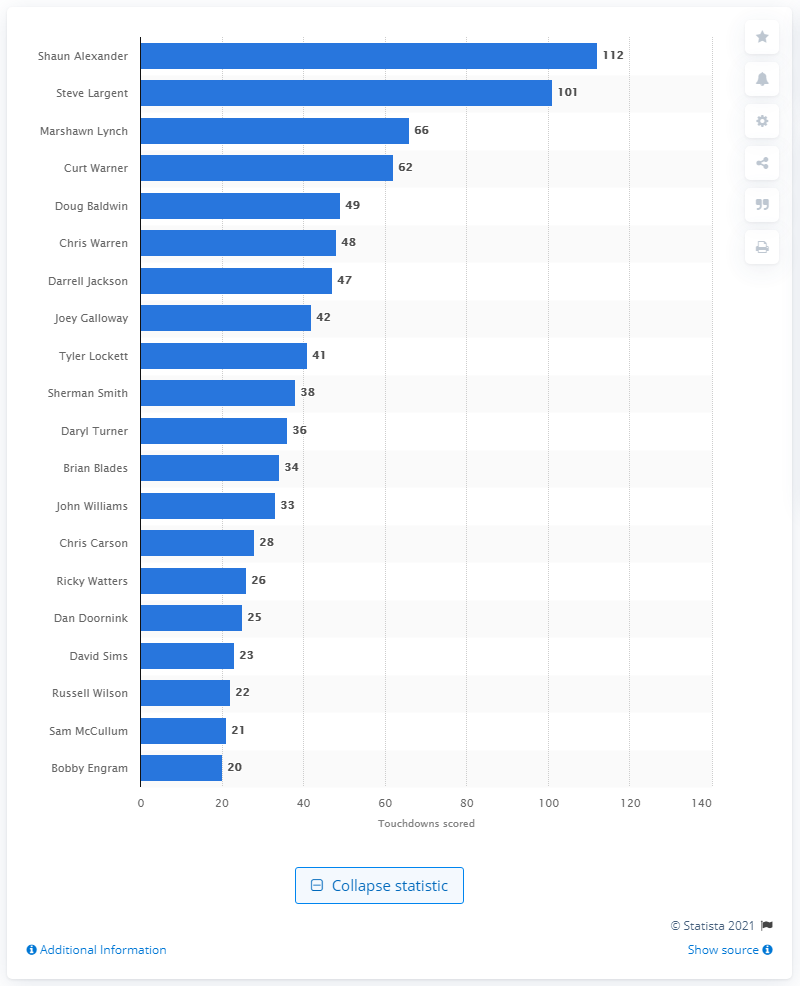Draw attention to some important aspects in this diagram. Shaun Alexander has scored a total of 112 touchdowns. The career touchdown leader of the Seattle Seahawks is Shaun Alexander. 